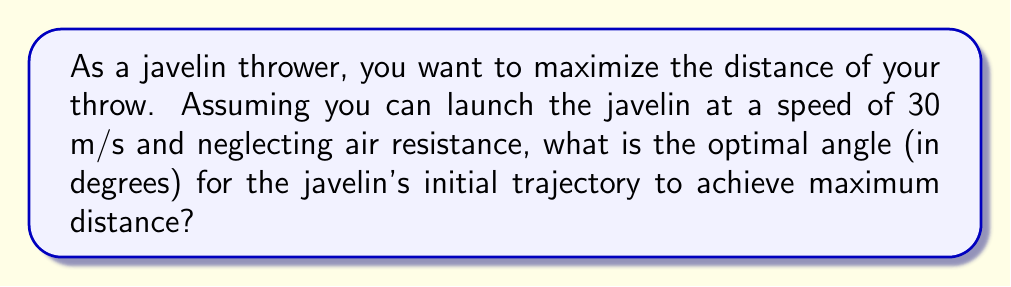Solve this math problem. To solve this problem, we'll follow these steps:

1) The range (R) of a projectile launched at an angle θ with initial velocity v₀ is given by:

   $$R = \frac{v_0^2 \sin(2\theta)}{g}$$

   where g is the acceleration due to gravity (9.8 m/s²).

2) To find the maximum range, we need to maximize sin(2θ). The maximum value of sine is 1, which occurs when its argument is 90°.

3) Therefore, for maximum range:

   $$2\theta = 90°$$

4) Solving for θ:

   $$\theta = 45°$$

5) This result is independent of the initial velocity and only depends on the projectile motion in a uniform gravitational field without air resistance.

6) For a disciplined athlete focusing on physical technique, remembering this 45° angle can help maintain consistency in throws without requiring complex mental calculations during performance.
Answer: 45° 